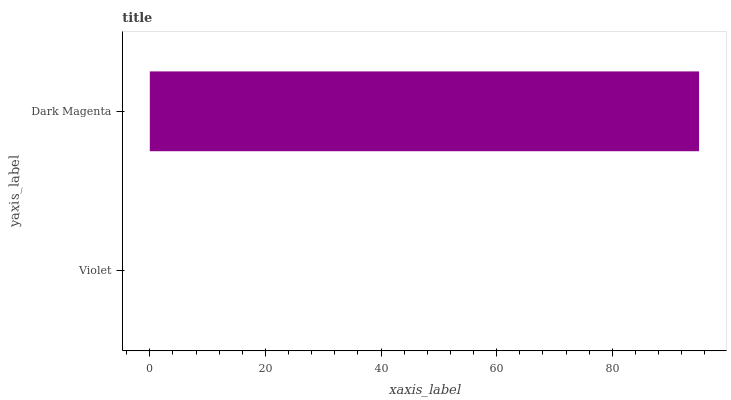Is Violet the minimum?
Answer yes or no. Yes. Is Dark Magenta the maximum?
Answer yes or no. Yes. Is Dark Magenta the minimum?
Answer yes or no. No. Is Dark Magenta greater than Violet?
Answer yes or no. Yes. Is Violet less than Dark Magenta?
Answer yes or no. Yes. Is Violet greater than Dark Magenta?
Answer yes or no. No. Is Dark Magenta less than Violet?
Answer yes or no. No. Is Dark Magenta the high median?
Answer yes or no. Yes. Is Violet the low median?
Answer yes or no. Yes. Is Violet the high median?
Answer yes or no. No. Is Dark Magenta the low median?
Answer yes or no. No. 